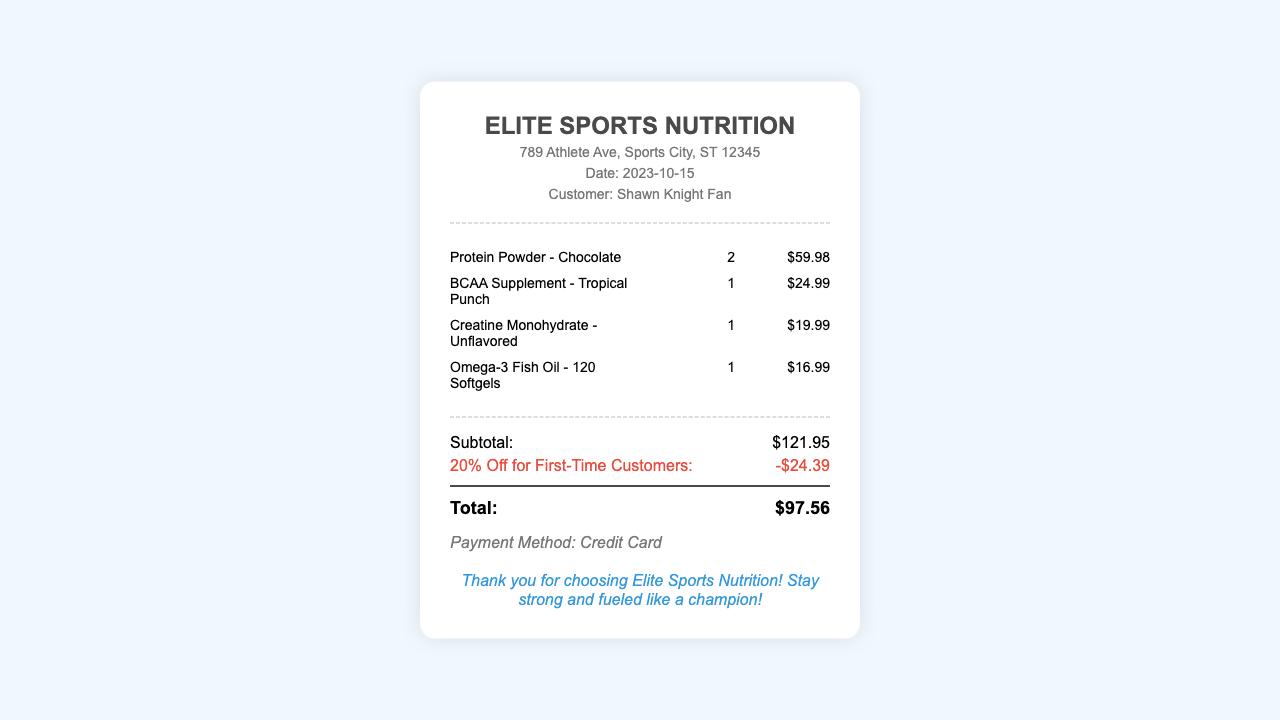What is the name of the store? The store's name is prominently displayed at the top of the document.
Answer: Elite Sports Nutrition What is the purchase date? The date of purchase is mentioned below the store name.
Answer: 2023-10-15 How many Protein Powder items were purchased? The quantity of Protein Powder purchased is listed alongside the item.
Answer: 2 What is the price of the BCAA Supplement? The price of the BCAA Supplement is displayed next to the item.
Answer: $24.99 What discount was applied to the order? The discount for first-time customers is mentioned in the totals section.
Answer: -$24.39 What is the subtotal of the order? The subtotal is calculated before any discounts are applied, shown in the totals section.
Answer: $121.95 What is the total cost after discounts? The total cost reflects the final amount after the discount is applied.
Answer: $97.56 What payment method was used? The payment method is specified in the receipt.
Answer: Credit Card Who is the customer? The customer's name is noted in the header section of the document.
Answer: Shawn Knight Fan 